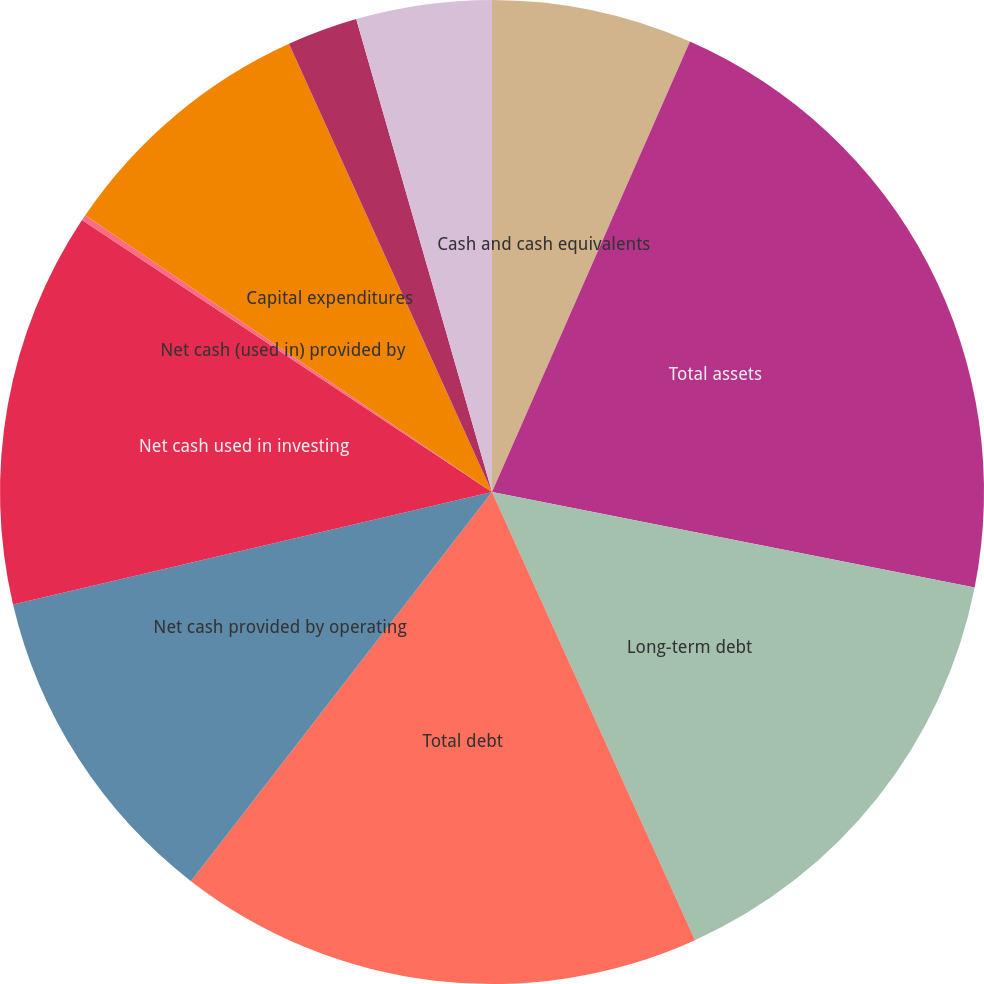Convert chart to OTSL. <chart><loc_0><loc_0><loc_500><loc_500><pie_chart><fcel>Cash and cash equivalents<fcel>Total assets<fcel>Long-term debt<fcel>Total debt<fcel>Net cash provided by operating<fcel>Net cash used in investing<fcel>Net cash (used in) provided by<fcel>Capital expenditures<fcel>Purchases of treasury stock<fcel>Dividends paid<nl><fcel>6.59%<fcel>21.52%<fcel>15.12%<fcel>17.25%<fcel>10.85%<fcel>12.99%<fcel>0.19%<fcel>8.72%<fcel>2.32%<fcel>4.45%<nl></chart> 